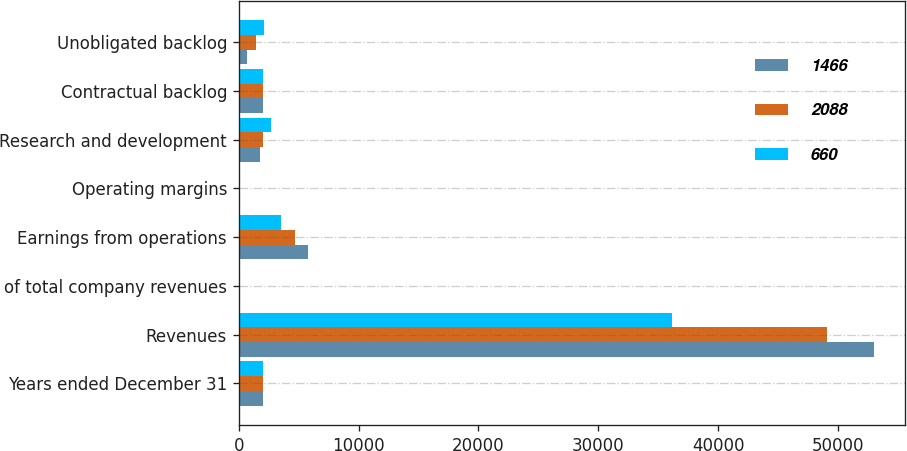Convert chart. <chart><loc_0><loc_0><loc_500><loc_500><stacked_bar_chart><ecel><fcel>Years ended December 31<fcel>Revenues<fcel>of total company revenues<fcel>Earnings from operations<fcel>Operating margins<fcel>Research and development<fcel>Contractual backlog<fcel>Unobligated backlog<nl><fcel>1466<fcel>2013<fcel>52981<fcel>61<fcel>5795<fcel>10.9<fcel>1807<fcel>2012<fcel>660<nl><fcel>2088<fcel>2012<fcel>49127<fcel>60<fcel>4711<fcel>9.6<fcel>2049<fcel>2012<fcel>1466<nl><fcel>660<fcel>2011<fcel>36171<fcel>53<fcel>3495<fcel>9.7<fcel>2715<fcel>2012<fcel>2088<nl></chart> 